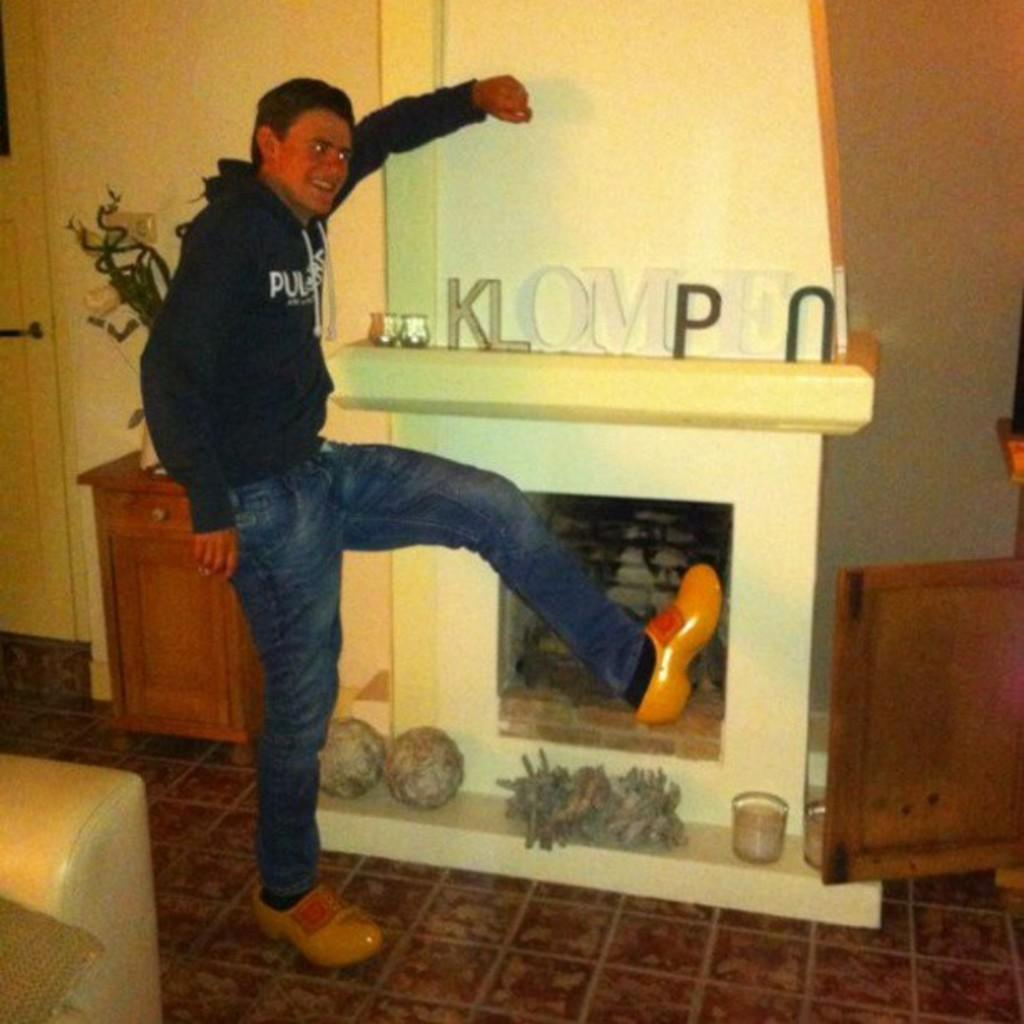What is the man doing in the image? The man is on the floor in the image. What type of furniture is present in the image? There is a sofa in the image. What can be seen in the background of the image? There are houseplants, a table, a door, and a wall in the background of the image. Where might this image have been taken? The image may have been taken in a hall. What type of action is the minister taking with the pig in the image? There is no minister or pig present in the image. 